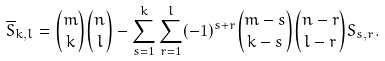Convert formula to latex. <formula><loc_0><loc_0><loc_500><loc_500>{ \overline { S } _ { k , l } } = { { m } \choose k } { { n } \choose l } - \sum ^ { k } _ { s = 1 } \sum ^ { l } _ { r = 1 } ( - 1 ) ^ { s + r } { { m - s } \choose k - s } { { n - r } \choose l - r } S _ { s , r } .</formula> 